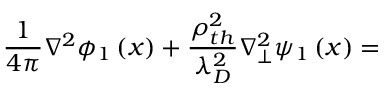<formula> <loc_0><loc_0><loc_500><loc_500>\frac { 1 } { 4 \pi } \nabla ^ { 2 } \phi _ { 1 } \left ( x \right ) + \frac { \rho _ { t h } ^ { 2 } } { \lambda _ { D } ^ { 2 } } \nabla _ { \perp } ^ { 2 } \psi _ { 1 } \left ( x \right ) =</formula> 